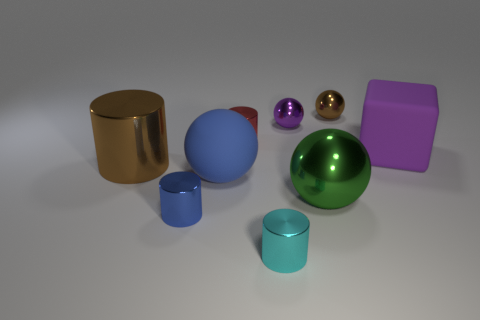Does the metal cylinder that is left of the blue cylinder have the same size as the small red metal cylinder?
Offer a terse response. No. What is the color of the block that is the same size as the brown metal cylinder?
Keep it short and to the point. Purple. Is there a small thing on the left side of the tiny metallic cylinder that is in front of the blue thing that is in front of the blue rubber object?
Make the answer very short. Yes. What is the tiny ball right of the green ball made of?
Your answer should be very brief. Metal. Is the shape of the big green object the same as the large matte object to the left of the purple matte object?
Your answer should be compact. Yes. Is the number of large shiny spheres that are to the right of the big purple block the same as the number of cyan metallic objects that are on the right side of the purple ball?
Your answer should be very brief. Yes. How many other things are made of the same material as the brown sphere?
Your answer should be compact. 6. What number of matte objects are large blue spheres or purple blocks?
Ensure brevity in your answer.  2. There is a brown object that is behind the tiny red shiny cylinder; is it the same shape as the tiny purple thing?
Keep it short and to the point. Yes. Is the number of small purple metallic things left of the green shiny thing greater than the number of tiny matte things?
Ensure brevity in your answer.  Yes. 